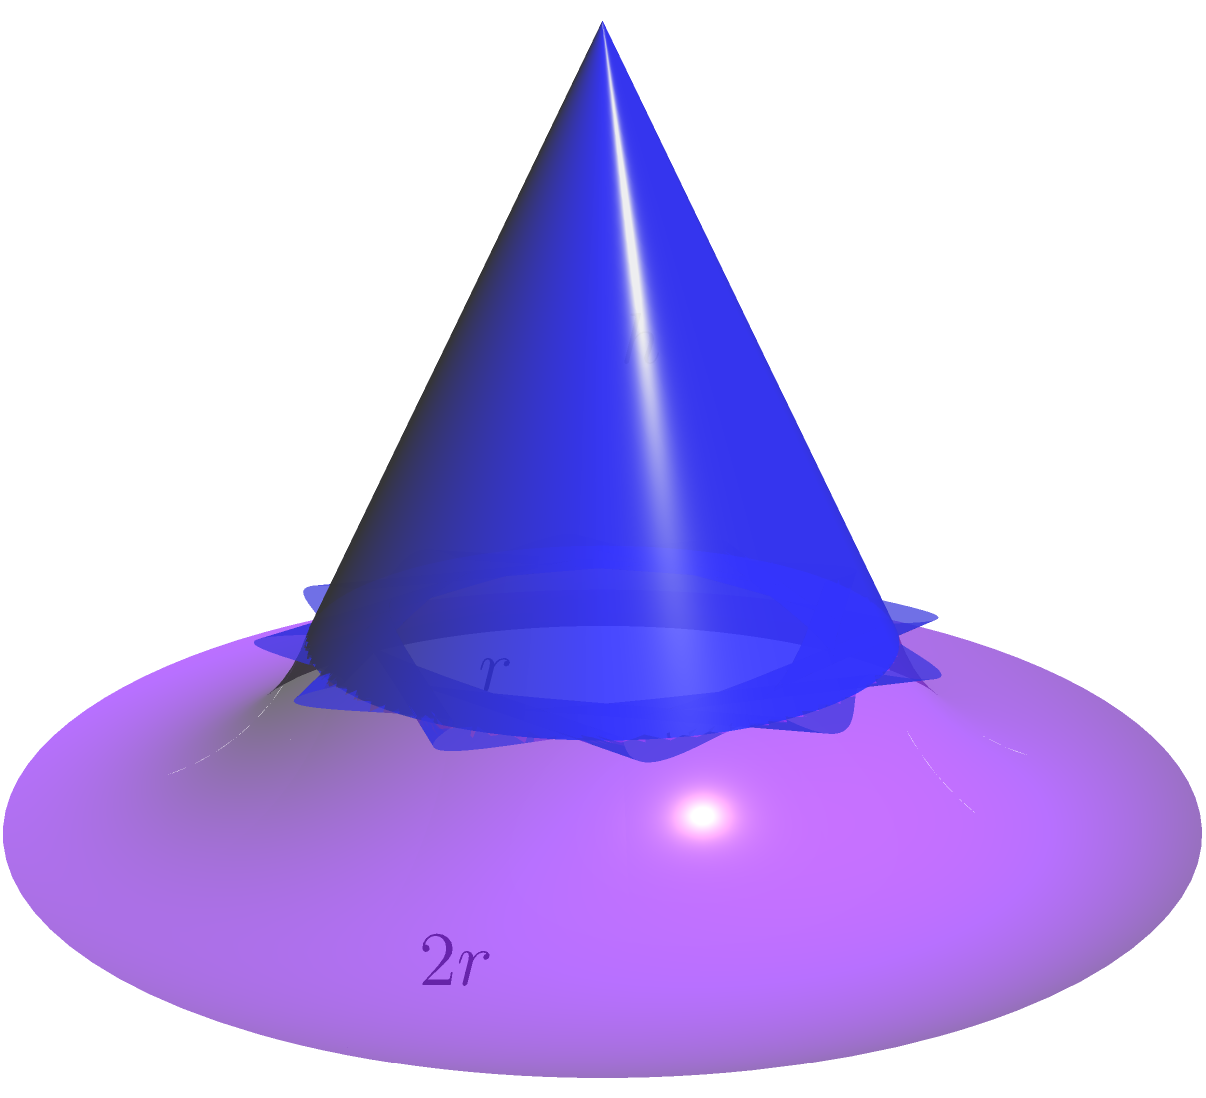In a whimsical tale, you encounter a wizard whose hat resembles a cone with a curved brim. The conical part of the hat has a radius of 2 units and a height of 4 units. The brim extends outward, curving downward to form a semicircle with a radius equal to the hat's base radius. Calculate the total volume of the wizard's hat, including both the conical portion and the curved brim. Let's approach this magical problem step by step:

1. Calculate the volume of the conical part:
   The volume of a cone is given by $V_{cone} = \frac{1}{3}\pi r^2 h$
   Where $r = 2$ and $h = 4$
   $V_{cone} = \frac{1}{3}\pi (2^2) (4) = \frac{16}{3}\pi$ cubic units

2. Calculate the volume of the curved brim:
   The brim forms half of a torus (donut shape) with the inner radius equal to the hat's base radius.
   Volume of a torus is given by $V_{torus} = 2\pi^2 R r^2$
   Where $R$ is the distance from the center of the tube to the center of the torus,
   and $r$ is the radius of the tube.

   In this case, $R = r = 2$ (the hat's base radius)
   The brim is half of this torus, so we'll divide by 2.

   $V_{brim} = \frac{1}{2} (2\pi^2 (2) (2^2)) = 8\pi^2$ cubic units

3. Sum up the volumes:
   $V_{total} = V_{cone} + V_{brim} = \frac{16}{3}\pi + 8\pi^2$ cubic units

4. Simplify:
   $V_{total} = \frac{16\pi + 24\pi^2}{3}$ cubic units
Answer: $\frac{16\pi + 24\pi^2}{3}$ cubic units 